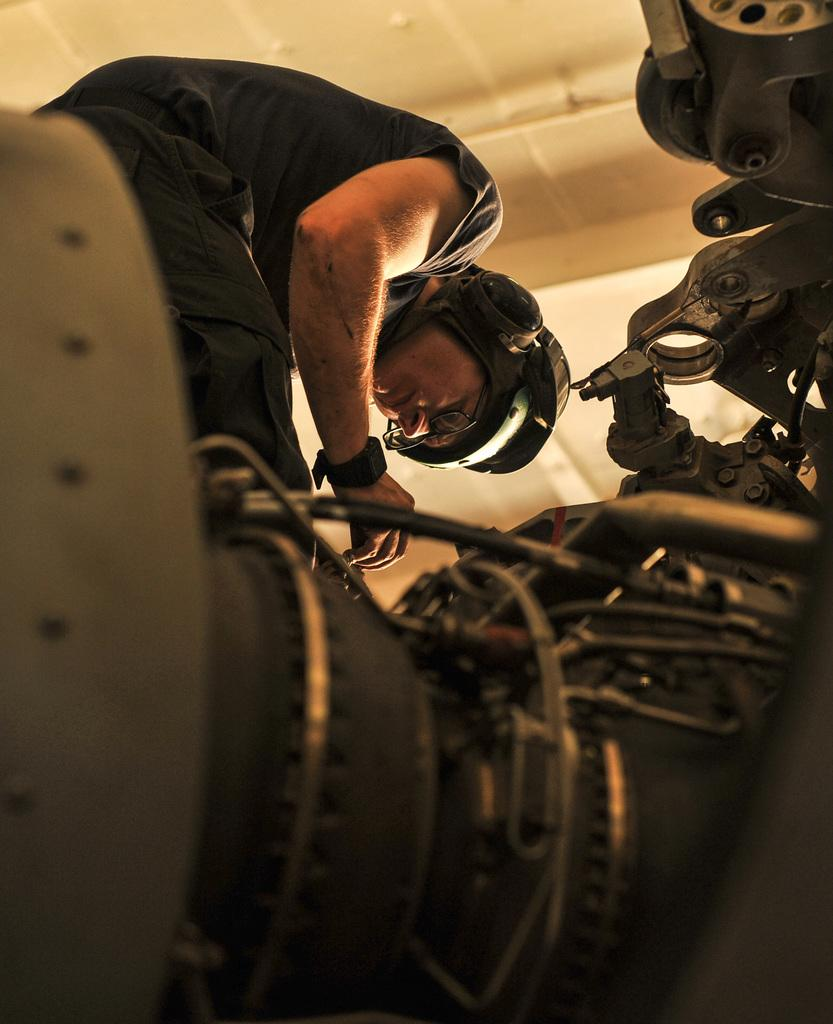What is the main subject of the image? There is a person in the image. What is the person wearing on their head? The person is wearing a helmet. What type of clothing is the person wearing? The person is wearing a black dress. What accessories can be seen on the person? The person is wearing spectacles and a watch. What vehicle is present in the image? There is a motorbike in the image. How many dimes can be seen on the person's wrist in the image? There are no dimes visible on the person's wrist in the image. What type of top is the person wearing in the image? The person is not wearing a top; they are wearing a black dress. 